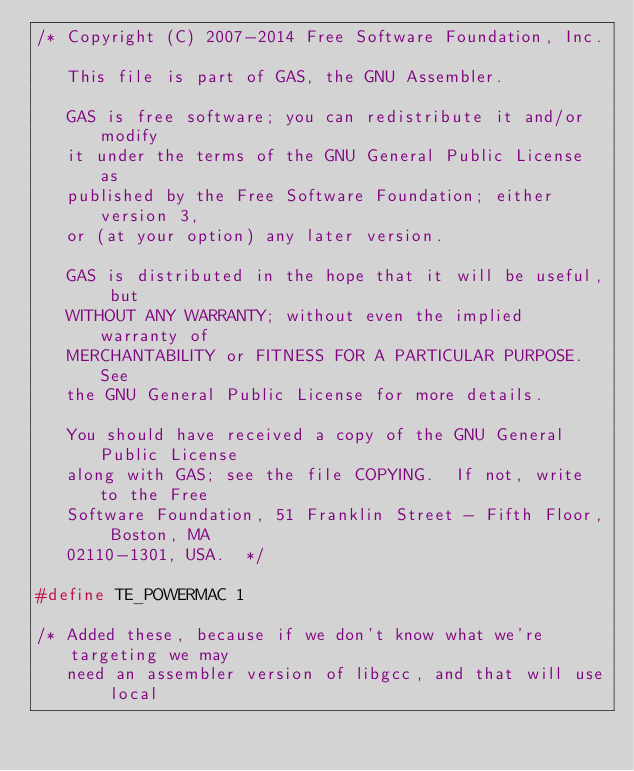<code> <loc_0><loc_0><loc_500><loc_500><_C_>/* Copyright (C) 2007-2014 Free Software Foundation, Inc.

   This file is part of GAS, the GNU Assembler.

   GAS is free software; you can redistribute it and/or modify
   it under the terms of the GNU General Public License as
   published by the Free Software Foundation; either version 3,
   or (at your option) any later version.

   GAS is distributed in the hope that it will be useful, but
   WITHOUT ANY WARRANTY; without even the implied warranty of
   MERCHANTABILITY or FITNESS FOR A PARTICULAR PURPOSE.  See
   the GNU General Public License for more details.

   You should have received a copy of the GNU General Public License
   along with GAS; see the file COPYING.  If not, write to the Free
   Software Foundation, 51 Franklin Street - Fifth Floor, Boston, MA
   02110-1301, USA.  */

#define TE_POWERMAC 1

/* Added these, because if we don't know what we're targeting we may
   need an assembler version of libgcc, and that will use local</code> 